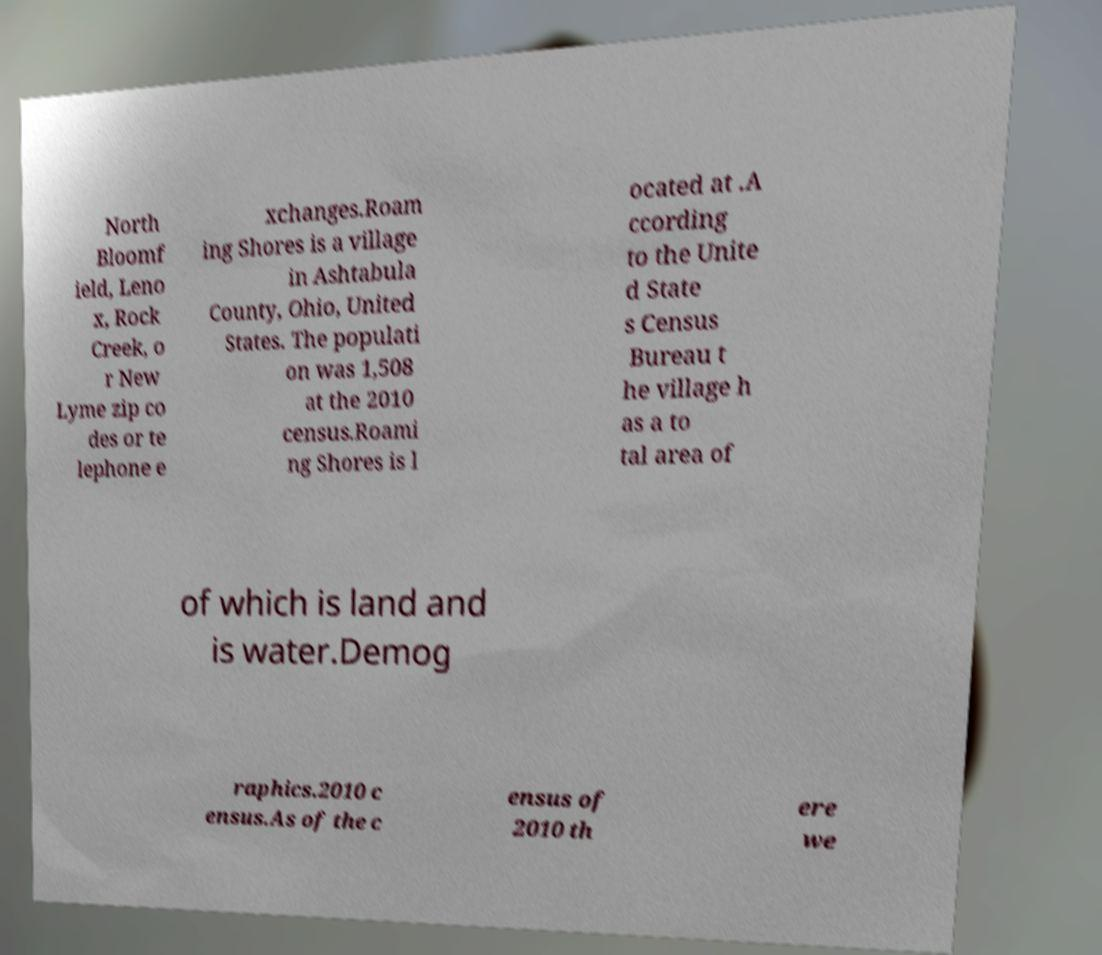What messages or text are displayed in this image? I need them in a readable, typed format. North Bloomf ield, Leno x, Rock Creek, o r New Lyme zip co des or te lephone e xchanges.Roam ing Shores is a village in Ashtabula County, Ohio, United States. The populati on was 1,508 at the 2010 census.Roami ng Shores is l ocated at .A ccording to the Unite d State s Census Bureau t he village h as a to tal area of of which is land and is water.Demog raphics.2010 c ensus.As of the c ensus of 2010 th ere we 